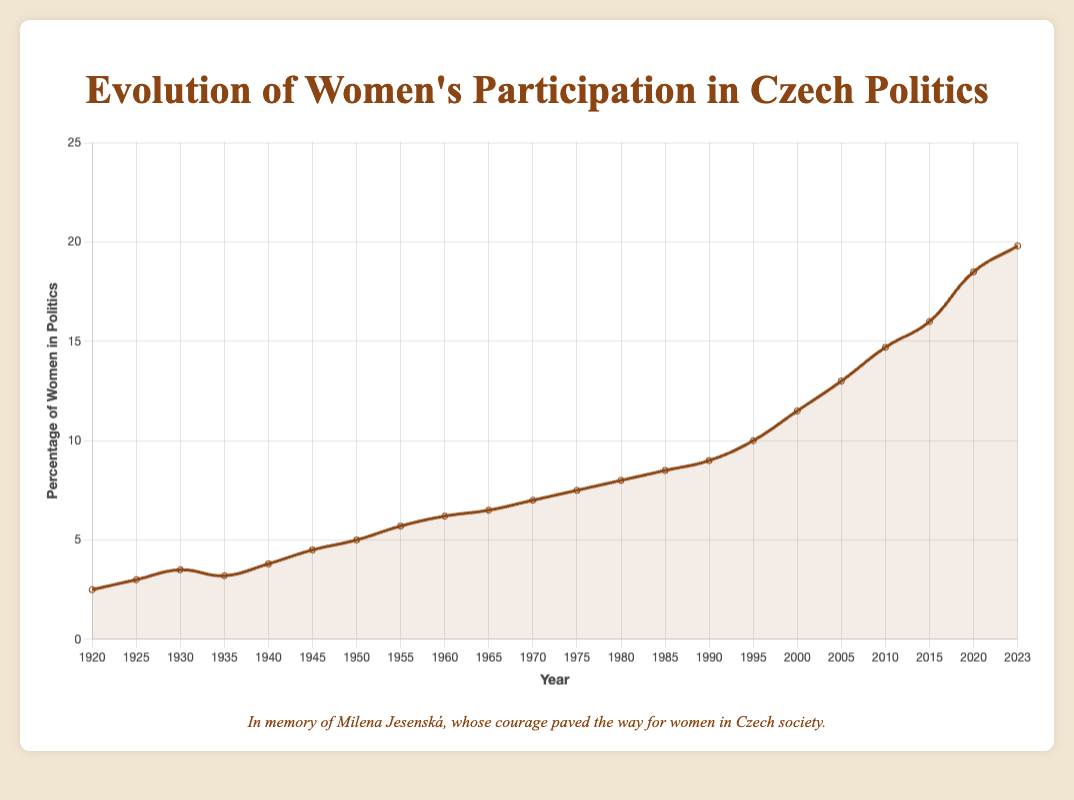What is the percentage of women in politics in 1920? Look at the data point on the line chart corresponding to the year 1920. The percentage of women in politics in 1920 is given.
Answer: 2.5% How has the percentage of women in politics changed from 1925 to 1935? Find the data points for the years 1925 and 1935. Subtract the percentage in 1925 from the percentage in 1935 to find the change.
Answer: 0.2% In which year did the percentage of women in politics first reach 10%? Examine the data points along the line chart to find the first instance where the percentage reaches or exceeds 10%.
Answer: 1995 What is the approximate rate of increase in women's participation in Czech politics from 1990 to 2000? Calculate the difference in percentages between 1990 (9%) and 2000 (11.5%). Then divide this difference by the number of years between these two points to get the average annual increase.
Answer: 0.25% per year Which decade observed the largest increase in women's participation in politics? Compare the percentage of women in politics at the beginning and end of each decade. The decade with the largest positive difference is the one with the largest increase.
Answer: 2010-2020 What was the percentage increase in women’s political participation from 1945 to 1985? Subtract the percentage in 1945 (4.5%) from the percentage in 1985 (8.5%) to get the increase.
Answer: 4% Determine the median percentage of women in politics from 1920 to 2023. Arrange the percentages in ascending order and find the middle value. With an even number of data points (22), the median is the average of the 11th and 12th values. (7.0% and 7.5%)
Answer: 7.25% What is the smallest increase in women’s participation over any five-year period? Calculate the differences for each consecutive five-year period. Identify the smallest difference.
Answer: 0.0% (between 1965 and 1970) Compare the percentage change in women's political participation between 1950-1960 to 2000-2010. Find the percentage increase from 1950 to 1960 (6.2% - 5.0%) and from 2000 to 2010 (14.7% - 11.5%). Compare these values.
Answer: 1.2% vs. 3.2% By how much did the percentage of women in politics increase between 2005 and 2015? Subtract the percentage in 2005 (13.0%) from the percentage in 2015 (16.0%).
Answer: 3% 